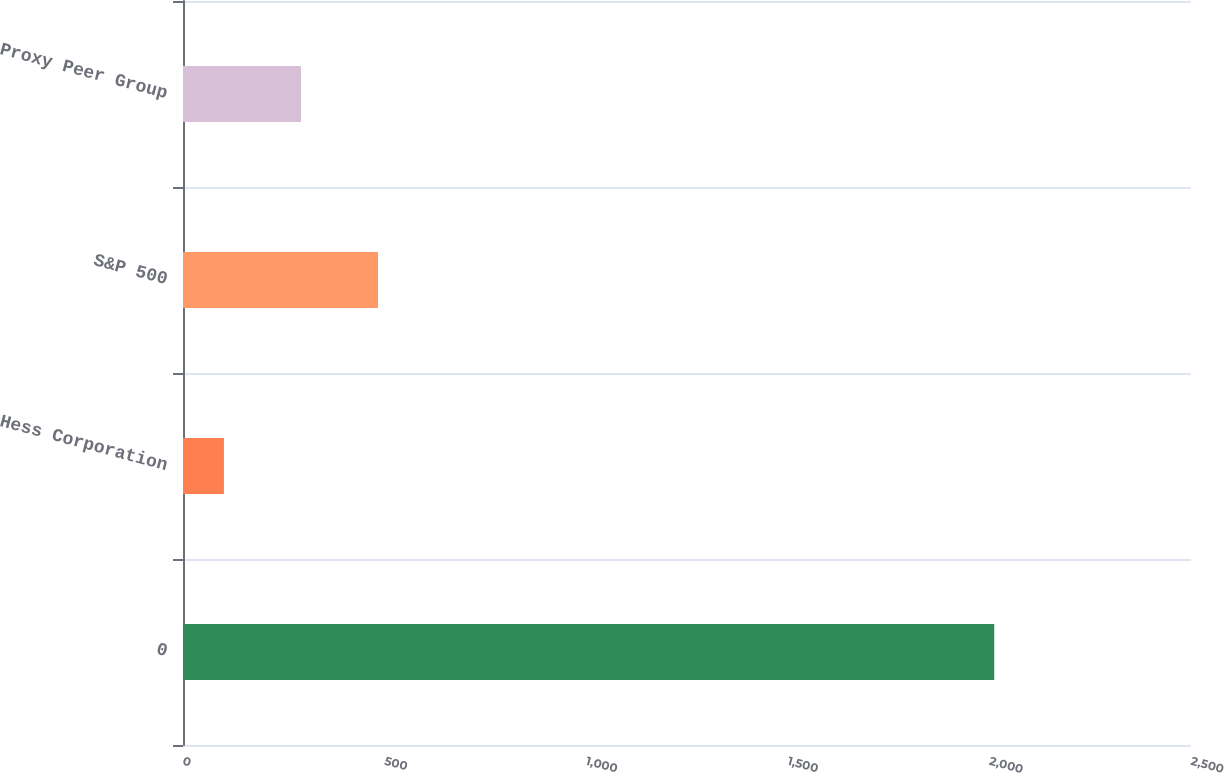<chart> <loc_0><loc_0><loc_500><loc_500><bar_chart><fcel>0<fcel>Hess Corporation<fcel>S&P 500<fcel>Proxy Peer Group<nl><fcel>2012<fcel>101.51<fcel>483.61<fcel>292.56<nl></chart> 